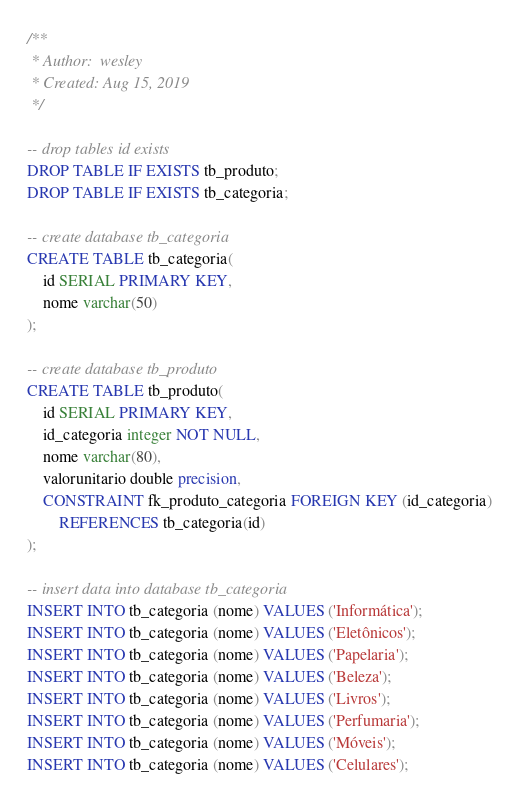<code> <loc_0><loc_0><loc_500><loc_500><_SQL_>/**
 * Author:  wesley
 * Created: Aug 15, 2019
 */

-- drop tables id exists
DROP TABLE IF EXISTS tb_produto;
DROP TABLE IF EXISTS tb_categoria;

-- create database tb_categoria
CREATE TABLE tb_categoria(
	id SERIAL PRIMARY KEY,
	nome varchar(50)
);

-- create database tb_produto
CREATE TABLE tb_produto(
	id SERIAL PRIMARY KEY,
	id_categoria integer NOT NULL,
	nome varchar(80),
	valorunitario double precision,
	CONSTRAINT fk_produto_categoria FOREIGN KEY (id_categoria) 
		REFERENCES tb_categoria(id)
);

-- insert data into database tb_categoria
INSERT INTO tb_categoria (nome) VALUES ('Informática');
INSERT INTO tb_categoria (nome) VALUES ('Eletônicos');
INSERT INTO tb_categoria (nome) VALUES ('Papelaria');
INSERT INTO tb_categoria (nome) VALUES ('Beleza');
INSERT INTO tb_categoria (nome) VALUES ('Livros');
INSERT INTO tb_categoria (nome) VALUES ('Perfumaria');
INSERT INTO tb_categoria (nome) VALUES ('Móveis');
INSERT INTO tb_categoria (nome) VALUES ('Celulares');
</code> 